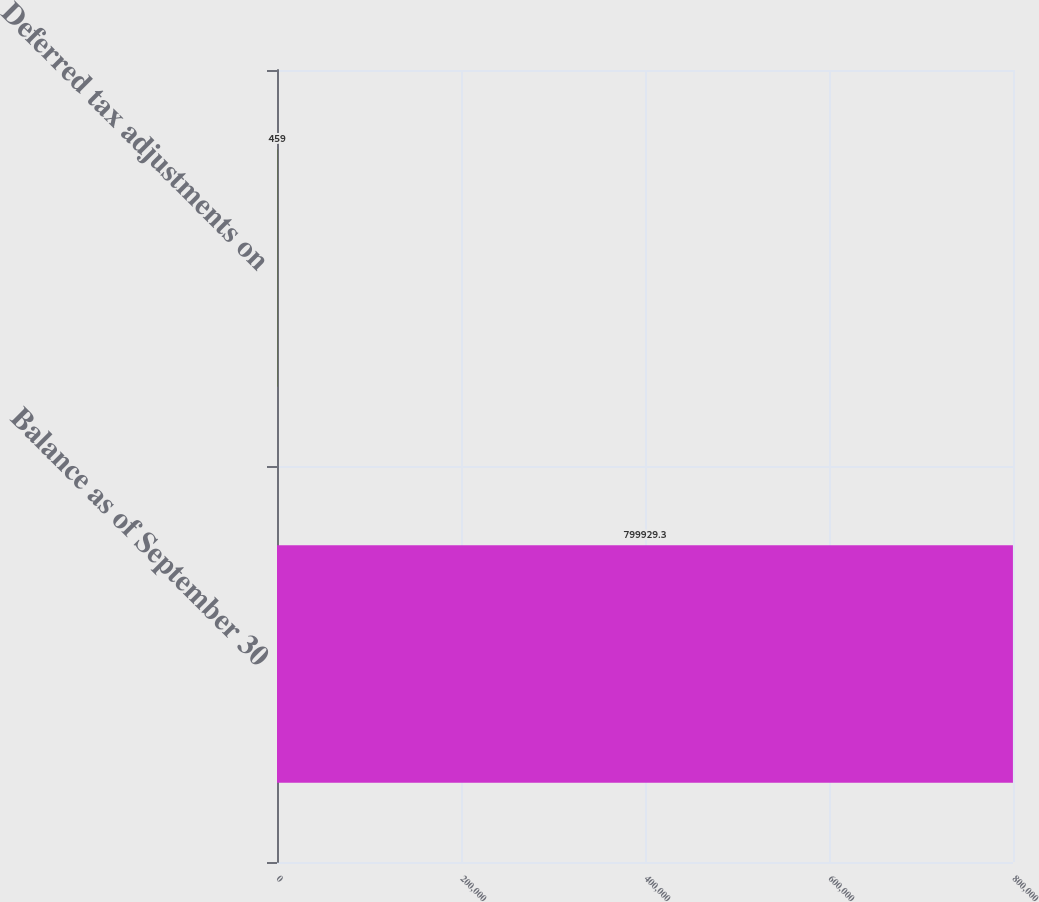<chart> <loc_0><loc_0><loc_500><loc_500><bar_chart><fcel>Balance as of September 30<fcel>Deferred tax adjustments on<nl><fcel>799929<fcel>459<nl></chart> 